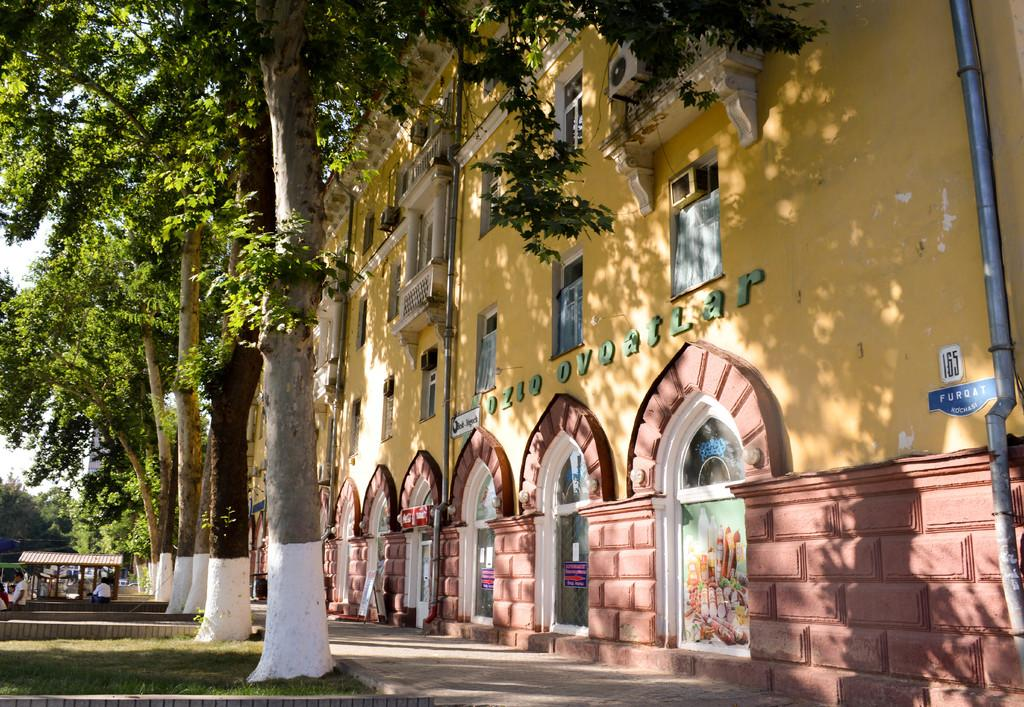What type of structures can be seen in the image? There are buildings in the image. What architectural features are present on the buildings? There are windows visible on the buildings. What type of vegetation is present in the image? There are trees in the image. What type of outbuildings can be seen in the image? There are sheds in the image. What type of infrastructure is present in the image? There are pipes in the image. Are there any people present in the image? Yes, there are people in the image. What type of signage or markings are present in the image? There are boards in the image. What is visible in the background of the image? The sky is visible in the image. What type of animal is depicted on the historical flesh-colored monument in the image? There is no animal depicted on a historical flesh-colored monument in the image, as none of the provided facts mention such a monument. 